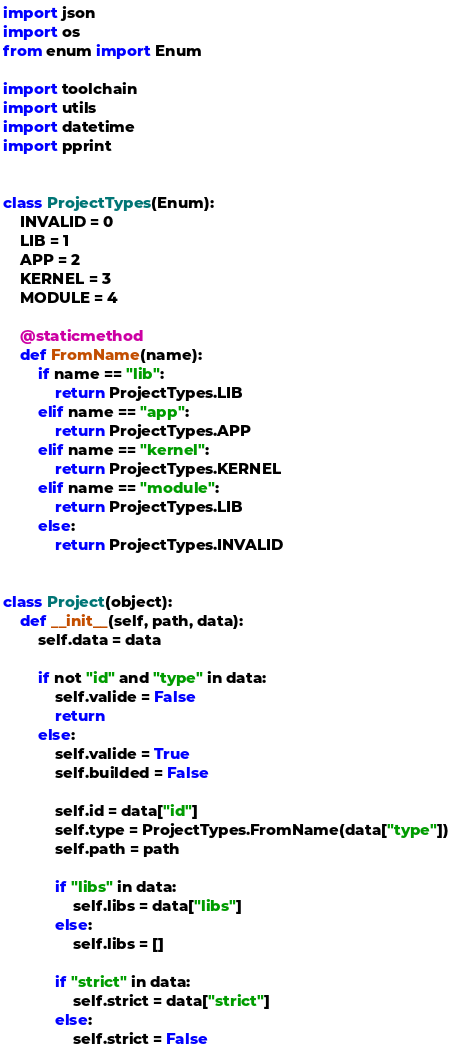<code> <loc_0><loc_0><loc_500><loc_500><_Python_>import json
import os
from enum import Enum

import toolchain
import utils
import datetime
import pprint


class ProjectTypes(Enum):
    INVALID = 0
    LIB = 1
    APP = 2
    KERNEL = 3
    MODULE = 4

    @staticmethod
    def FromName(name):
        if name == "lib":
            return ProjectTypes.LIB
        elif name == "app":
            return ProjectTypes.APP
        elif name == "kernel":
            return ProjectTypes.KERNEL
        elif name == "module":
            return ProjectTypes.LIB
        else:
            return ProjectTypes.INVALID


class Project(object):
    def __init__(self, path, data):
        self.data = data

        if not "id" and "type" in data:
            self.valide = False
            return
        else:
            self.valide = True
            self.builded = False

            self.id = data["id"]
            self.type = ProjectTypes.FromName(data["type"])
            self.path = path

            if "libs" in data:
                self.libs = data["libs"]
            else:
                self.libs = []

            if "strict" in data:
                self.strict = data["strict"]
            else:
                self.strict = False
</code> 